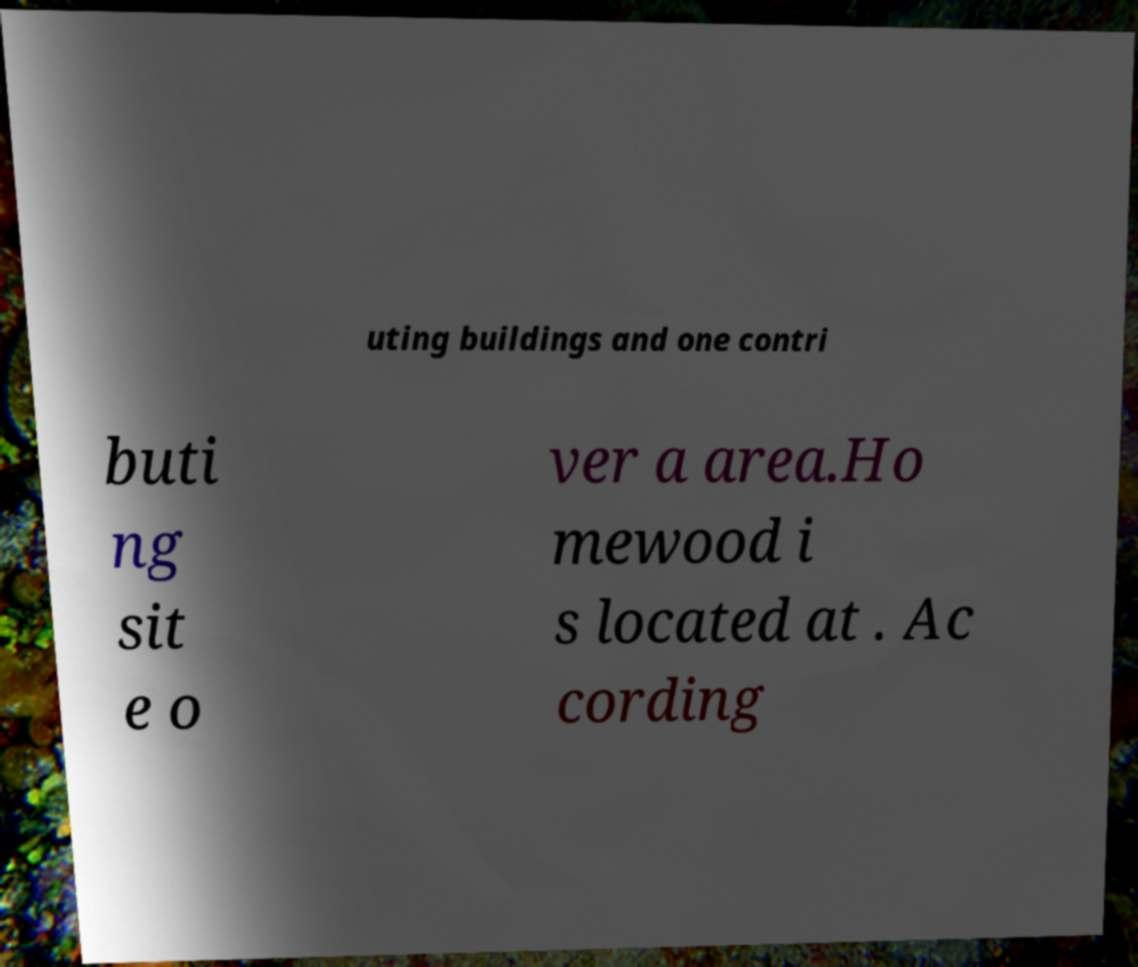I need the written content from this picture converted into text. Can you do that? uting buildings and one contri buti ng sit e o ver a area.Ho mewood i s located at . Ac cording 